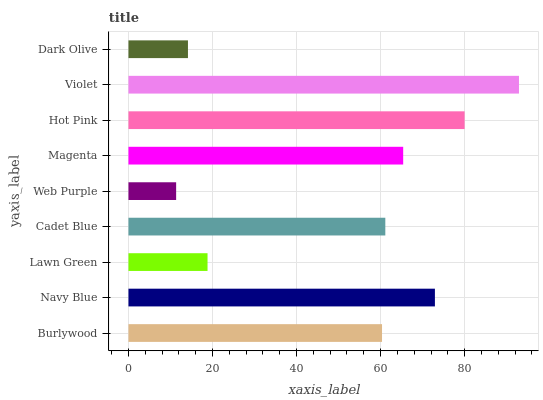Is Web Purple the minimum?
Answer yes or no. Yes. Is Violet the maximum?
Answer yes or no. Yes. Is Navy Blue the minimum?
Answer yes or no. No. Is Navy Blue the maximum?
Answer yes or no. No. Is Navy Blue greater than Burlywood?
Answer yes or no. Yes. Is Burlywood less than Navy Blue?
Answer yes or no. Yes. Is Burlywood greater than Navy Blue?
Answer yes or no. No. Is Navy Blue less than Burlywood?
Answer yes or no. No. Is Cadet Blue the high median?
Answer yes or no. Yes. Is Cadet Blue the low median?
Answer yes or no. Yes. Is Magenta the high median?
Answer yes or no. No. Is Dark Olive the low median?
Answer yes or no. No. 